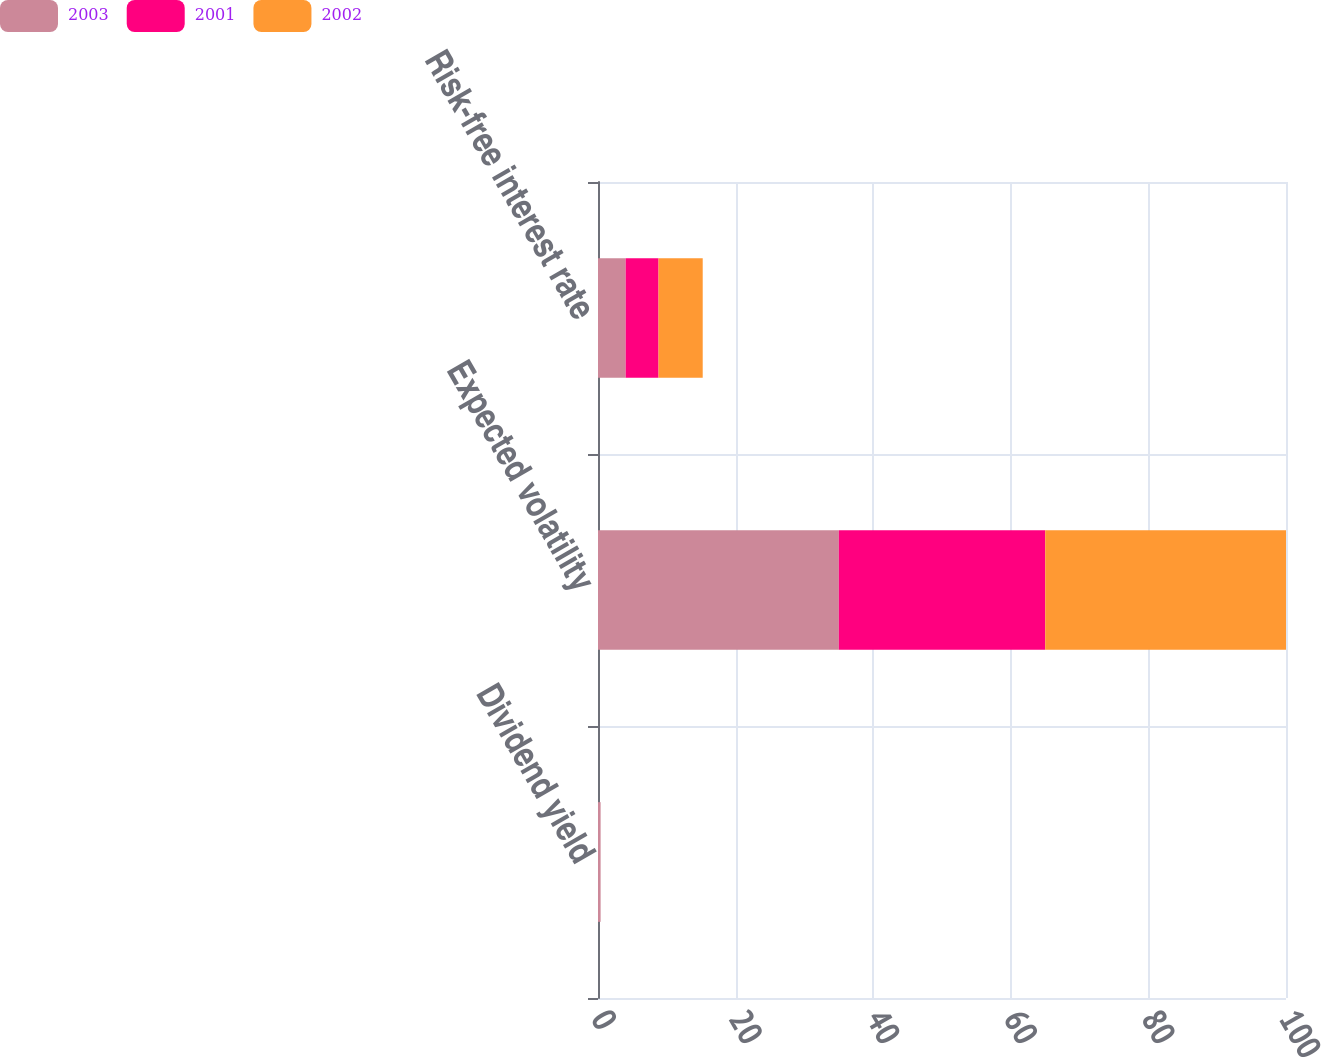<chart> <loc_0><loc_0><loc_500><loc_500><stacked_bar_chart><ecel><fcel>Dividend yield<fcel>Expected volatility<fcel>Risk-free interest rate<nl><fcel>2003<fcel>0.38<fcel>35<fcel>4.02<nl><fcel>2001<fcel>0<fcel>30<fcel>4.78<nl><fcel>2002<fcel>0<fcel>35<fcel>6.42<nl></chart> 